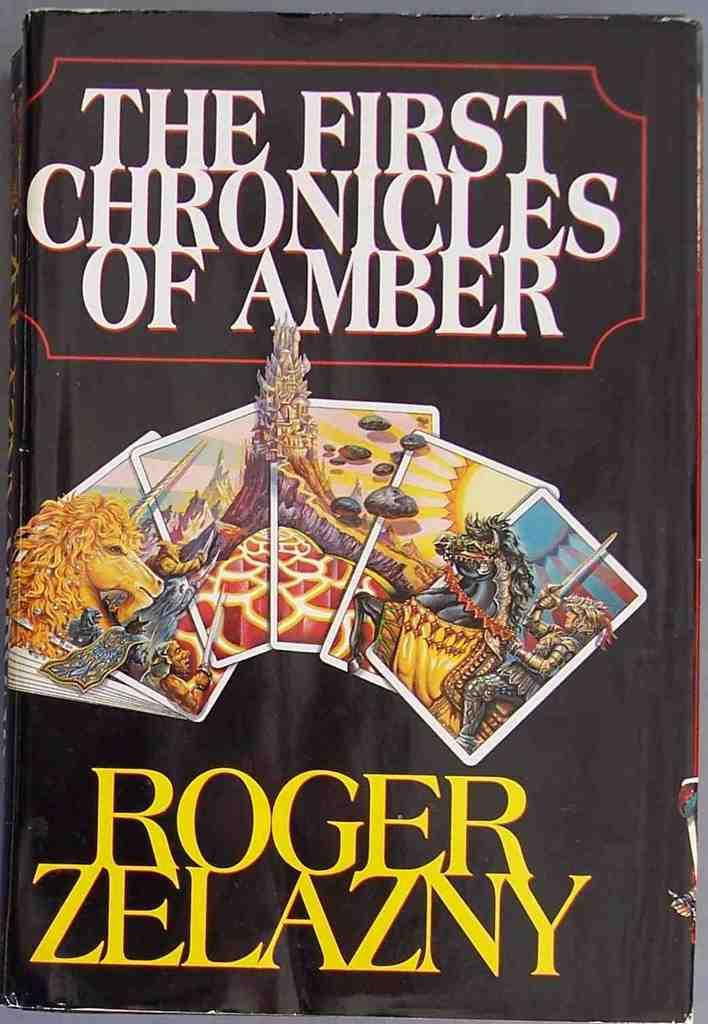<image>
Provide a brief description of the given image. The book cover of the First Chronicles of Amber. 